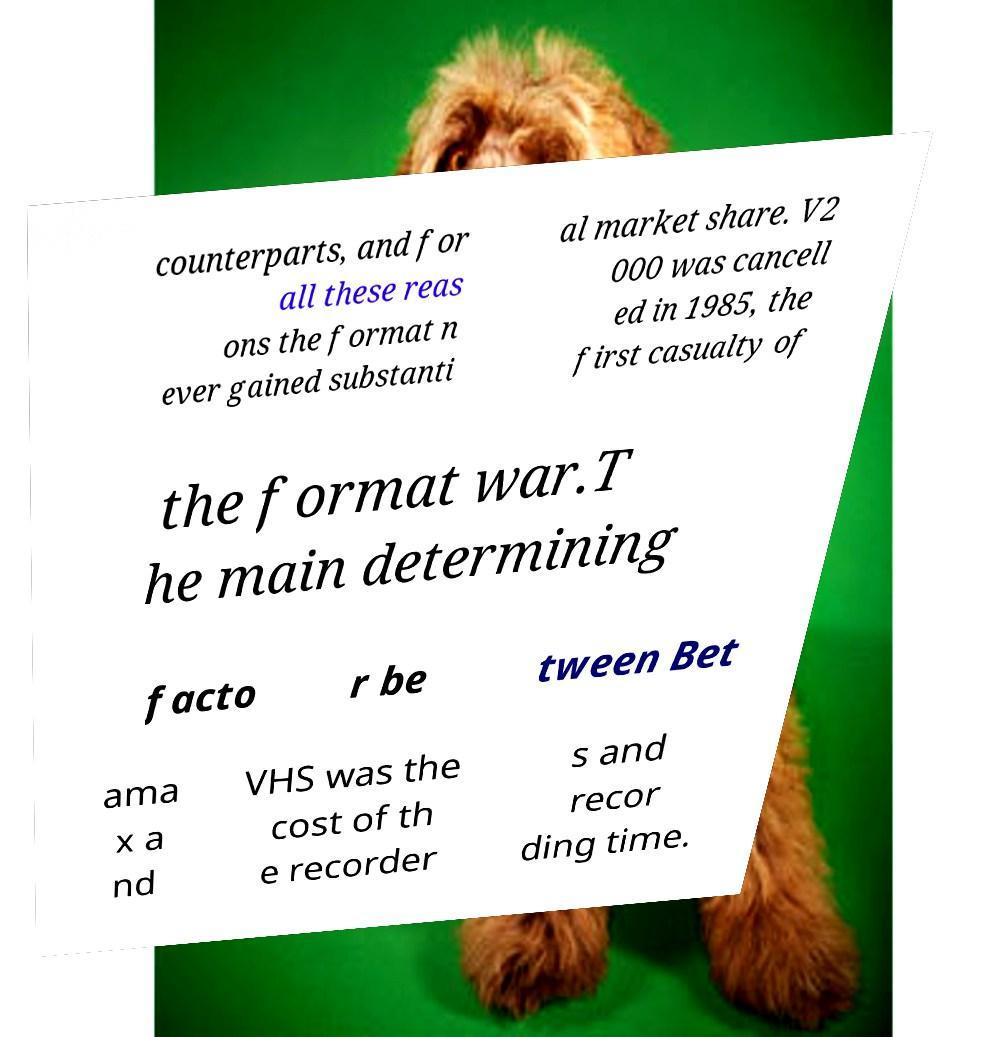For documentation purposes, I need the text within this image transcribed. Could you provide that? counterparts, and for all these reas ons the format n ever gained substanti al market share. V2 000 was cancell ed in 1985, the first casualty of the format war.T he main determining facto r be tween Bet ama x a nd VHS was the cost of th e recorder s and recor ding time. 